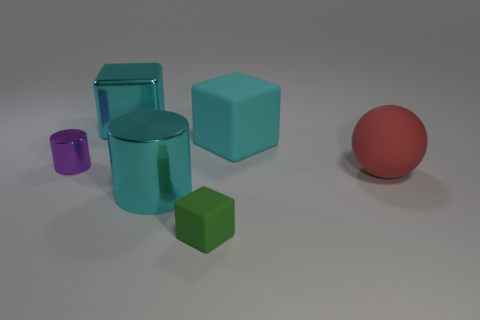Add 3 large cylinders. How many objects exist? 9 Subtract all spheres. How many objects are left? 5 Subtract 0 purple blocks. How many objects are left? 6 Subtract all tiny purple matte spheres. Subtract all cyan metal cubes. How many objects are left? 5 Add 5 big red things. How many big red things are left? 6 Add 5 red things. How many red things exist? 6 